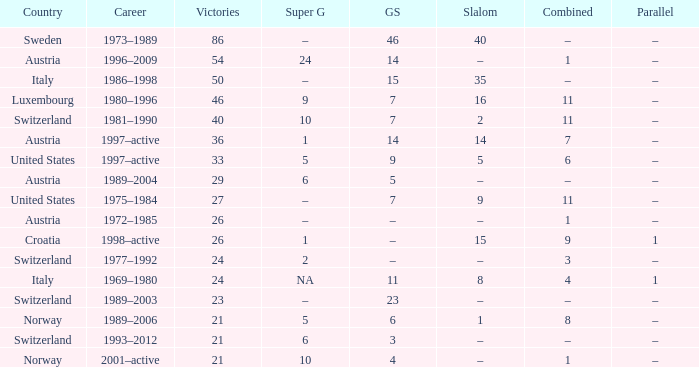What Giant Slalom has Victories larger than 27, a Slalom of –, and a Career of 1996–2009? 14.0. 